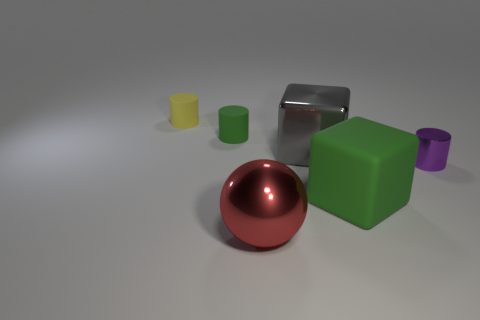Does the green rubber block in front of the yellow cylinder have the same size as the rubber cylinder that is in front of the small yellow cylinder?
Give a very brief answer. No. How many other objects are there of the same size as the sphere?
Keep it short and to the point. 2. What is the material of the tiny thing that is to the left of the green thing behind the small cylinder to the right of the big ball?
Your answer should be compact. Rubber. There is a shiny ball; is it the same size as the yellow thing behind the small shiny cylinder?
Offer a very short reply. No. What is the size of the rubber object that is right of the yellow cylinder and behind the small purple metallic object?
Give a very brief answer. Small. Is there a object that has the same color as the big matte block?
Keep it short and to the point. Yes. There is a big shiny object that is in front of the green rubber thing to the right of the red object; what is its color?
Your response must be concise. Red. Is the number of large balls that are on the right side of the small purple object less than the number of metallic things behind the big red metallic sphere?
Offer a terse response. Yes. Is the ball the same size as the purple thing?
Keep it short and to the point. No. What is the shape of the object that is in front of the small purple metal cylinder and behind the metallic sphere?
Give a very brief answer. Cube. 